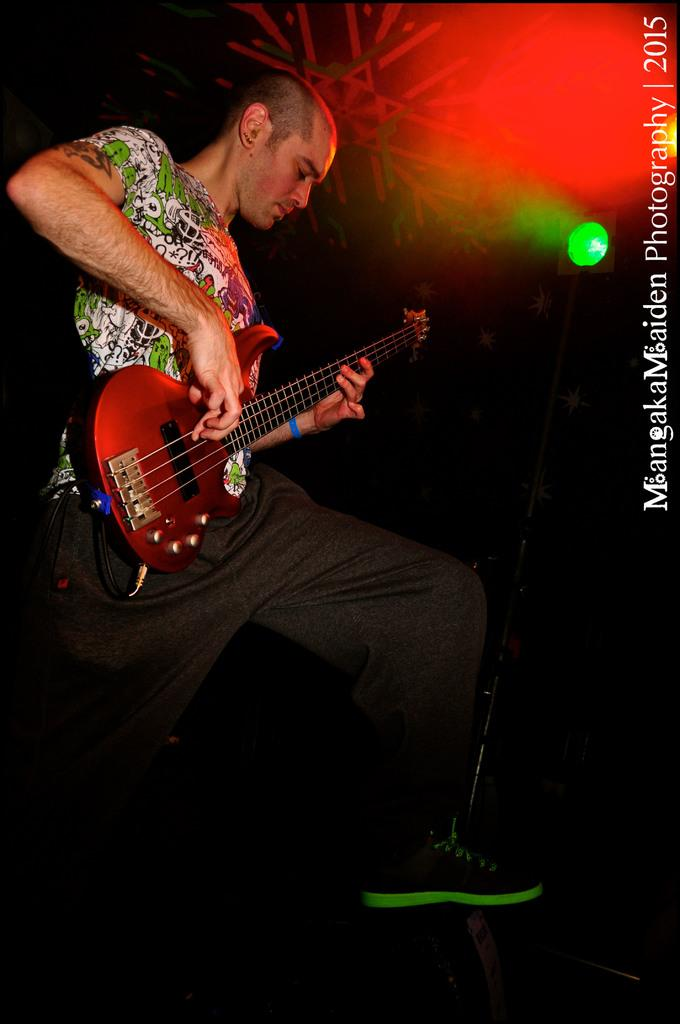What is the main subject of the image? There is a man in the image. What is the man doing in the image? The man is standing in the image. What is the man wearing on his upper body? The man is wearing a green and white t-shirt in the image. What is the man holding in the image? The man is holding a guitar in the image. What is the man wearing on his feet? The man is wearing shoes in the image. What type of twig is the man using to play the guitar in the image? There is no twig present in the image; the man is holding a guitar. What animal can be seen interacting with the man in the image? There are no animals present in the image; it only features the man and the guitar. 